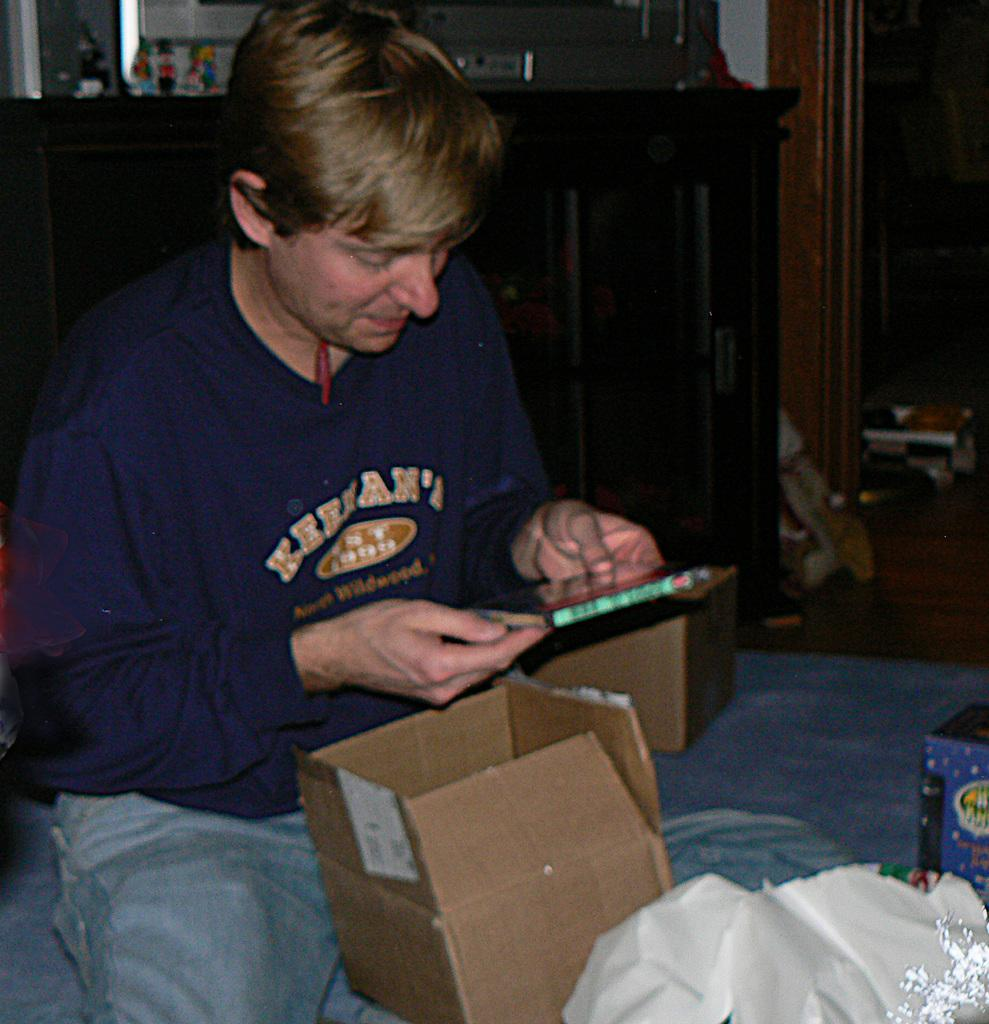Who is present in the image? There is a man in the image. What is the man doing in the image? The man is holding an object in his hands. What can be seen on the floor in the image? There are boxes and other objects on the floor. What is the name of the country where the aftermath of the event took place in the image? There is no event or country mentioned in the image; it only shows a man holding an object and boxes on the floor. What type of rake is being used to clean up the mess in the image? There is no rake or mess present in the image. 